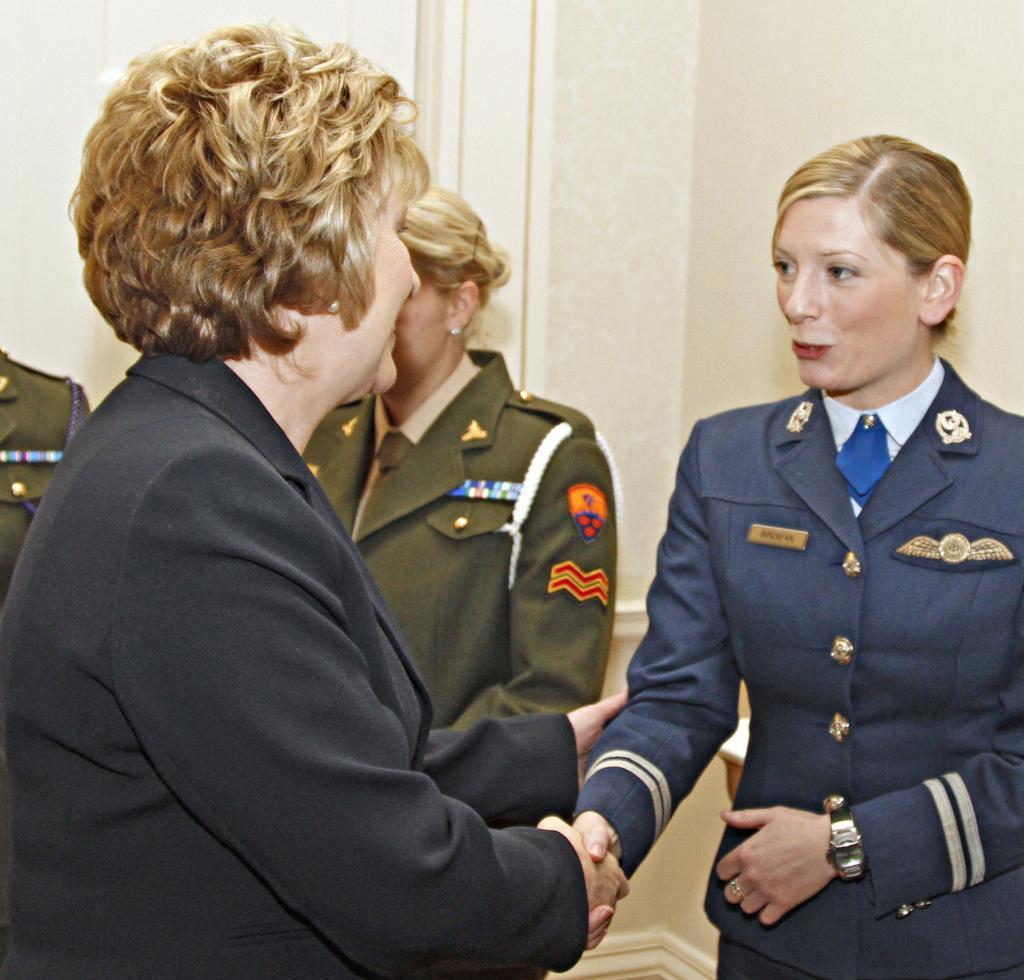Can you describe this image briefly? On the left side of the image we can see a lady is standing and smiling and wearing a suit and shaking hand to another lady. In the background of the image we can see the wall and three people are standing and wearing the uniforms. 